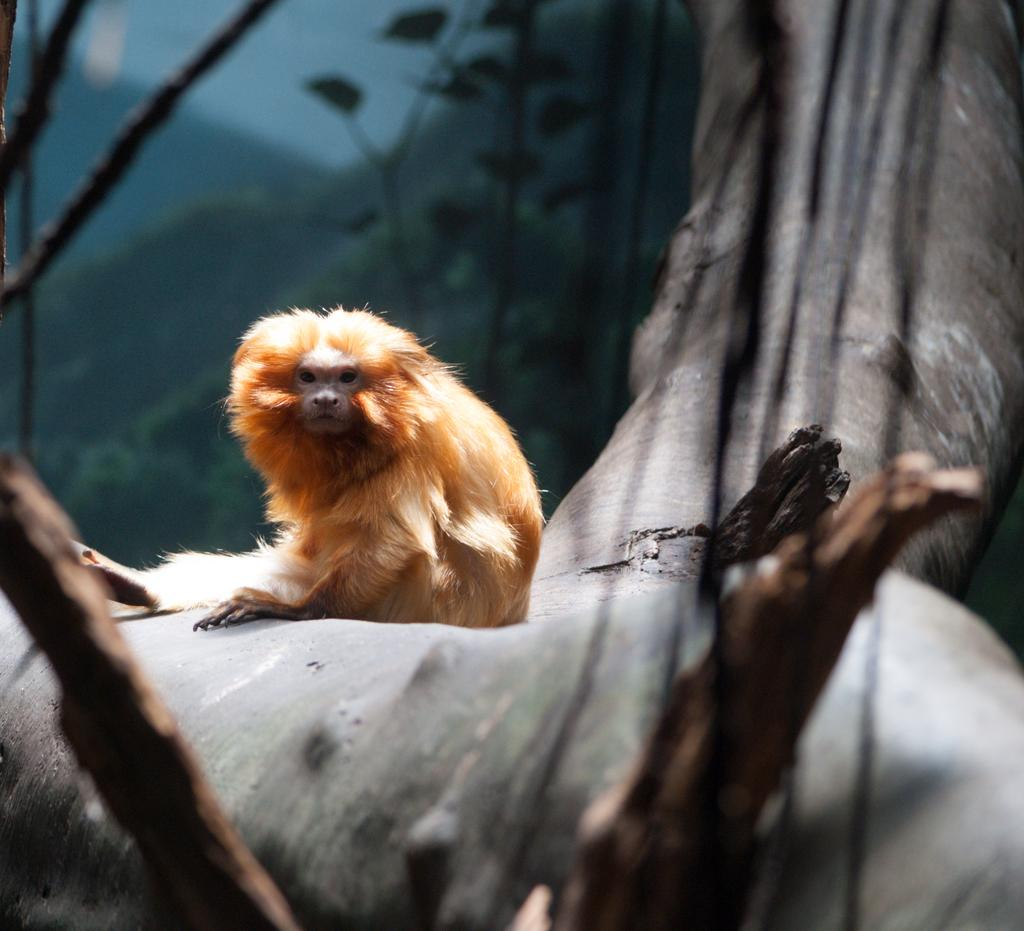What type of animal can be seen in the picture? There is an animal in the picture, but its specific type cannot be determined from the provided facts. Where is the animal located in the image? The animal is sitting on the trunk of a tree. What can be seen in the background of the image? There are trees in the background of the image. Can you see any fairies flying around the animal in the image? There is no mention of fairies in the image, so we cannot determine their presence or absence. 